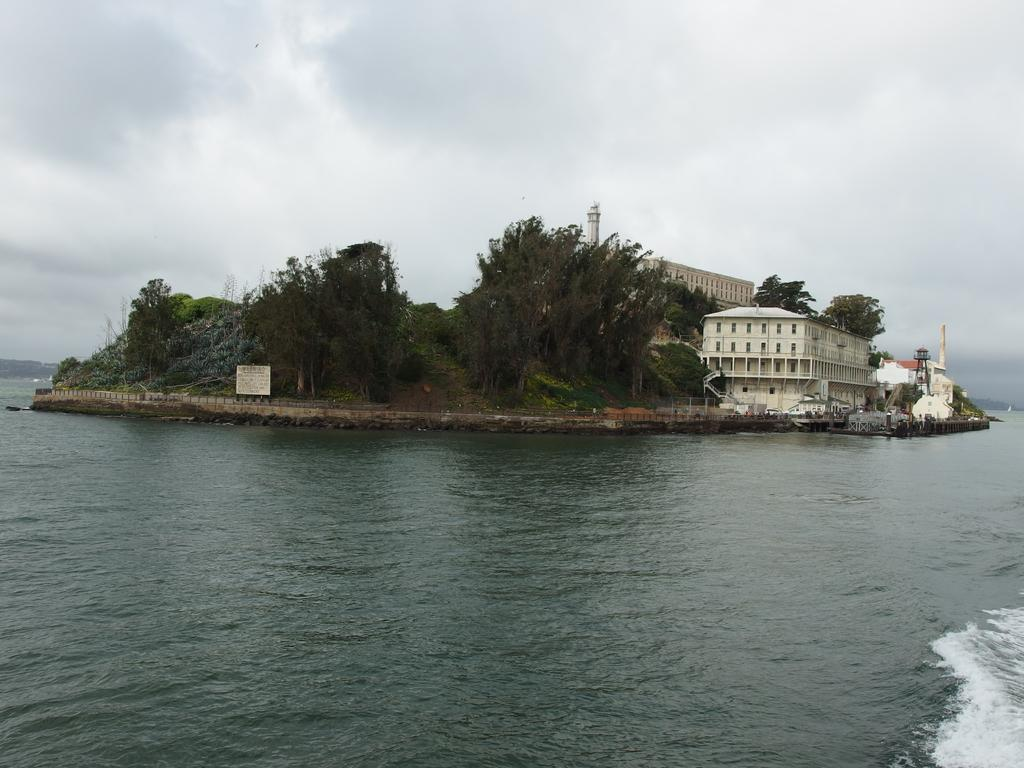What is located at the bottom of the image? There is water at the bottom of the image. What can be seen in the middle of the image? There are trees in the middle of the image. What type of structures are on the right side of the image? There are houses on the right side of the image. What is visible at the top of the image? The sky is visible at the top of the image. How would you describe the sky in the image? The sky appears to be cloudy. What type of appliance is being used to treat the disease in the image? There is no appliance or disease present in the image. How many passengers are visible in the image? There are no passengers present in the image. 